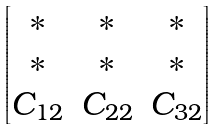Convert formula to latex. <formula><loc_0><loc_0><loc_500><loc_500>\begin{bmatrix} \ast & \ast & \ast \\ \ast & \ast & \ast \\ C _ { 1 2 } & C _ { 2 2 } & C _ { 3 2 } \end{bmatrix}</formula> 